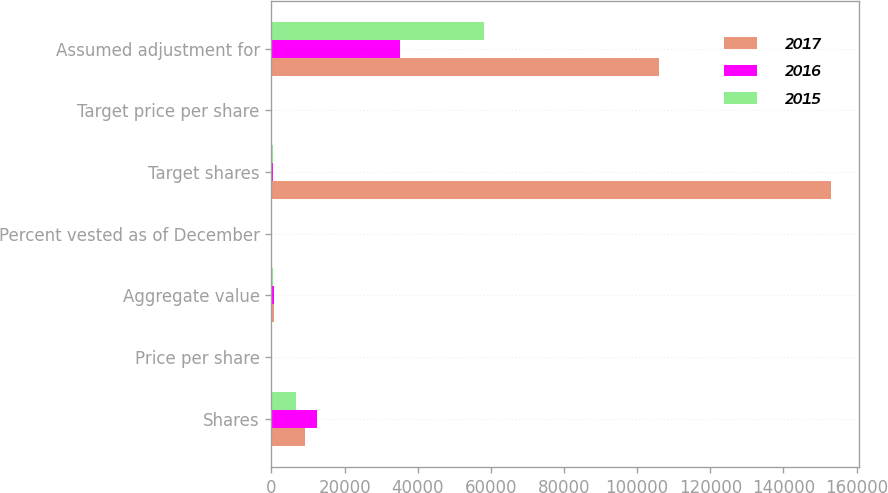Convert chart to OTSL. <chart><loc_0><loc_0><loc_500><loc_500><stacked_bar_chart><ecel><fcel>Shares<fcel>Price per share<fcel>Aggregate value<fcel>Percent vested as of December<fcel>Target shares<fcel>Target price per share<fcel>Assumed adjustment for<nl><fcel>2017<fcel>9135<fcel>73.92<fcel>675<fcel>100<fcel>153000<fcel>77.26<fcel>106084<nl><fcel>2016<fcel>12549<fcel>57.39<fcel>720<fcel>85<fcel>360<fcel>50.64<fcel>35073<nl><fcel>2015<fcel>6648<fcel>54.16<fcel>360<fcel>100<fcel>360<fcel>53.61<fcel>58056<nl></chart> 